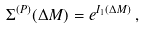<formula> <loc_0><loc_0><loc_500><loc_500>\Sigma ^ { ( P ) } ( \Delta M ) = e ^ { I _ { 1 } ( \Delta M ) } \, ,</formula> 